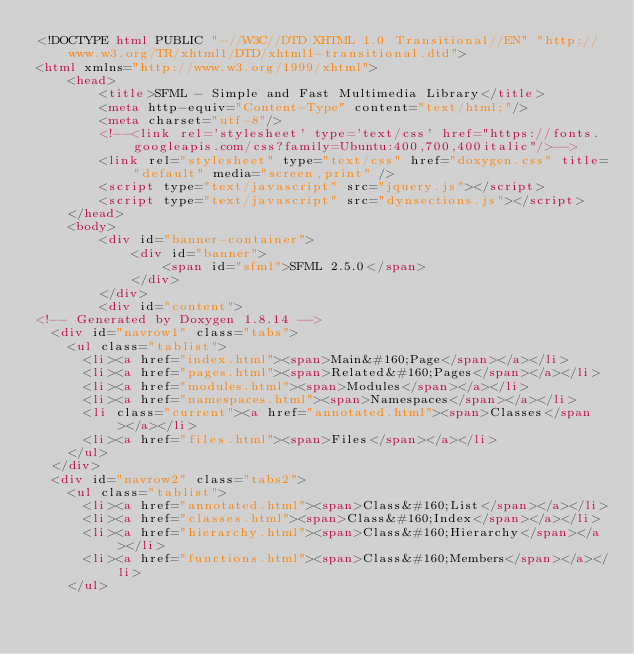Convert code to text. <code><loc_0><loc_0><loc_500><loc_500><_HTML_><!DOCTYPE html PUBLIC "-//W3C//DTD XHTML 1.0 Transitional//EN" "http://www.w3.org/TR/xhtml1/DTD/xhtml1-transitional.dtd">
<html xmlns="http://www.w3.org/1999/xhtml">
    <head>
        <title>SFML - Simple and Fast Multimedia Library</title>
        <meta http-equiv="Content-Type" content="text/html;"/>
        <meta charset="utf-8"/>
        <!--<link rel='stylesheet' type='text/css' href="https://fonts.googleapis.com/css?family=Ubuntu:400,700,400italic"/>-->
        <link rel="stylesheet" type="text/css" href="doxygen.css" title="default" media="screen,print" />
        <script type="text/javascript" src="jquery.js"></script>
        <script type="text/javascript" src="dynsections.js"></script>
    </head>
    <body>
        <div id="banner-container">
            <div id="banner">
                <span id="sfml">SFML 2.5.0</span>
            </div>
        </div>
        <div id="content">
<!-- Generated by Doxygen 1.8.14 -->
  <div id="navrow1" class="tabs">
    <ul class="tablist">
      <li><a href="index.html"><span>Main&#160;Page</span></a></li>
      <li><a href="pages.html"><span>Related&#160;Pages</span></a></li>
      <li><a href="modules.html"><span>Modules</span></a></li>
      <li><a href="namespaces.html"><span>Namespaces</span></a></li>
      <li class="current"><a href="annotated.html"><span>Classes</span></a></li>
      <li><a href="files.html"><span>Files</span></a></li>
    </ul>
  </div>
  <div id="navrow2" class="tabs2">
    <ul class="tablist">
      <li><a href="annotated.html"><span>Class&#160;List</span></a></li>
      <li><a href="classes.html"><span>Class&#160;Index</span></a></li>
      <li><a href="hierarchy.html"><span>Class&#160;Hierarchy</span></a></li>
      <li><a href="functions.html"><span>Class&#160;Members</span></a></li>
    </ul></code> 